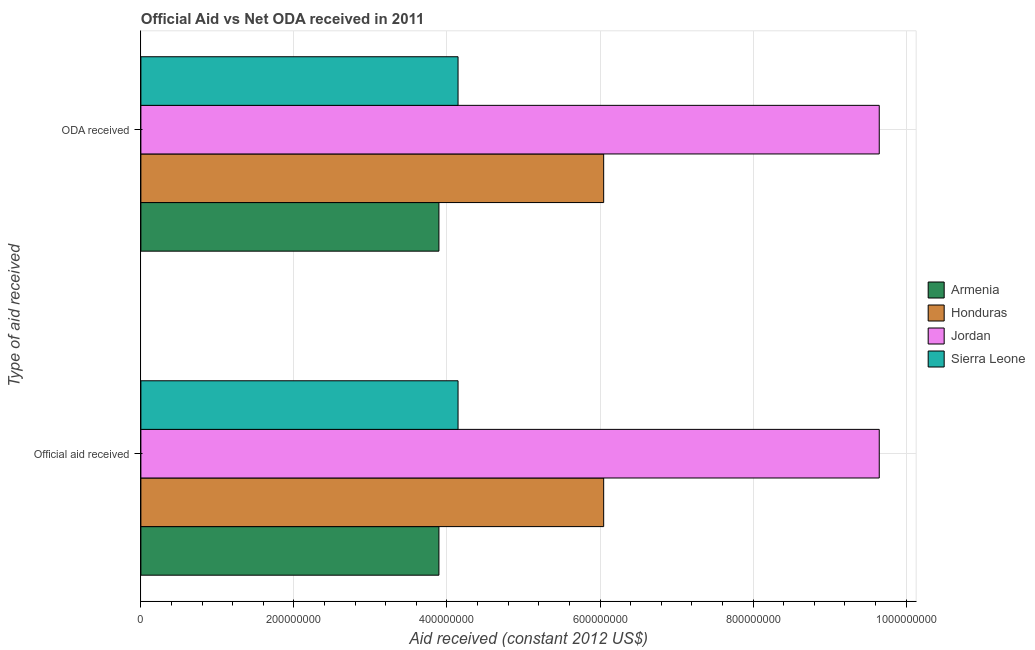How many groups of bars are there?
Ensure brevity in your answer.  2. How many bars are there on the 2nd tick from the top?
Offer a very short reply. 4. What is the label of the 1st group of bars from the top?
Provide a short and direct response. ODA received. What is the official aid received in Armenia?
Make the answer very short. 3.89e+08. Across all countries, what is the maximum official aid received?
Your response must be concise. 9.65e+08. Across all countries, what is the minimum oda received?
Give a very brief answer. 3.89e+08. In which country was the official aid received maximum?
Your answer should be compact. Jordan. In which country was the official aid received minimum?
Your answer should be very brief. Armenia. What is the total official aid received in the graph?
Provide a succinct answer. 2.37e+09. What is the difference between the official aid received in Armenia and that in Honduras?
Provide a succinct answer. -2.15e+08. What is the difference between the official aid received in Honduras and the oda received in Sierra Leone?
Ensure brevity in your answer.  1.90e+08. What is the average official aid received per country?
Provide a short and direct response. 5.93e+08. What is the ratio of the oda received in Armenia to that in Honduras?
Make the answer very short. 0.64. In how many countries, is the oda received greater than the average oda received taken over all countries?
Provide a succinct answer. 2. What does the 3rd bar from the top in ODA received represents?
Provide a succinct answer. Honduras. What does the 2nd bar from the bottom in Official aid received represents?
Provide a short and direct response. Honduras. How many bars are there?
Make the answer very short. 8. Are all the bars in the graph horizontal?
Keep it short and to the point. Yes. What is the difference between two consecutive major ticks on the X-axis?
Provide a succinct answer. 2.00e+08. Are the values on the major ticks of X-axis written in scientific E-notation?
Provide a succinct answer. No. Does the graph contain any zero values?
Keep it short and to the point. No. Does the graph contain grids?
Your answer should be compact. Yes. How many legend labels are there?
Make the answer very short. 4. How are the legend labels stacked?
Your answer should be compact. Vertical. What is the title of the graph?
Your answer should be compact. Official Aid vs Net ODA received in 2011 . What is the label or title of the X-axis?
Your answer should be compact. Aid received (constant 2012 US$). What is the label or title of the Y-axis?
Keep it short and to the point. Type of aid received. What is the Aid received (constant 2012 US$) in Armenia in Official aid received?
Give a very brief answer. 3.89e+08. What is the Aid received (constant 2012 US$) in Honduras in Official aid received?
Your response must be concise. 6.05e+08. What is the Aid received (constant 2012 US$) of Jordan in Official aid received?
Provide a short and direct response. 9.65e+08. What is the Aid received (constant 2012 US$) of Sierra Leone in Official aid received?
Offer a terse response. 4.14e+08. What is the Aid received (constant 2012 US$) of Armenia in ODA received?
Give a very brief answer. 3.89e+08. What is the Aid received (constant 2012 US$) in Honduras in ODA received?
Give a very brief answer. 6.05e+08. What is the Aid received (constant 2012 US$) of Jordan in ODA received?
Keep it short and to the point. 9.65e+08. What is the Aid received (constant 2012 US$) of Sierra Leone in ODA received?
Provide a succinct answer. 4.14e+08. Across all Type of aid received, what is the maximum Aid received (constant 2012 US$) of Armenia?
Offer a terse response. 3.89e+08. Across all Type of aid received, what is the maximum Aid received (constant 2012 US$) in Honduras?
Your answer should be very brief. 6.05e+08. Across all Type of aid received, what is the maximum Aid received (constant 2012 US$) in Jordan?
Your answer should be compact. 9.65e+08. Across all Type of aid received, what is the maximum Aid received (constant 2012 US$) in Sierra Leone?
Keep it short and to the point. 4.14e+08. Across all Type of aid received, what is the minimum Aid received (constant 2012 US$) in Armenia?
Ensure brevity in your answer.  3.89e+08. Across all Type of aid received, what is the minimum Aid received (constant 2012 US$) in Honduras?
Your answer should be compact. 6.05e+08. Across all Type of aid received, what is the minimum Aid received (constant 2012 US$) of Jordan?
Ensure brevity in your answer.  9.65e+08. Across all Type of aid received, what is the minimum Aid received (constant 2012 US$) in Sierra Leone?
Your answer should be compact. 4.14e+08. What is the total Aid received (constant 2012 US$) of Armenia in the graph?
Offer a terse response. 7.79e+08. What is the total Aid received (constant 2012 US$) of Honduras in the graph?
Your response must be concise. 1.21e+09. What is the total Aid received (constant 2012 US$) of Jordan in the graph?
Offer a very short reply. 1.93e+09. What is the total Aid received (constant 2012 US$) of Sierra Leone in the graph?
Provide a succinct answer. 8.29e+08. What is the difference between the Aid received (constant 2012 US$) of Jordan in Official aid received and that in ODA received?
Provide a short and direct response. 0. What is the difference between the Aid received (constant 2012 US$) in Sierra Leone in Official aid received and that in ODA received?
Ensure brevity in your answer.  0. What is the difference between the Aid received (constant 2012 US$) in Armenia in Official aid received and the Aid received (constant 2012 US$) in Honduras in ODA received?
Your response must be concise. -2.15e+08. What is the difference between the Aid received (constant 2012 US$) in Armenia in Official aid received and the Aid received (constant 2012 US$) in Jordan in ODA received?
Offer a terse response. -5.75e+08. What is the difference between the Aid received (constant 2012 US$) in Armenia in Official aid received and the Aid received (constant 2012 US$) in Sierra Leone in ODA received?
Provide a short and direct response. -2.50e+07. What is the difference between the Aid received (constant 2012 US$) in Honduras in Official aid received and the Aid received (constant 2012 US$) in Jordan in ODA received?
Your answer should be very brief. -3.60e+08. What is the difference between the Aid received (constant 2012 US$) in Honduras in Official aid received and the Aid received (constant 2012 US$) in Sierra Leone in ODA received?
Provide a short and direct response. 1.90e+08. What is the difference between the Aid received (constant 2012 US$) of Jordan in Official aid received and the Aid received (constant 2012 US$) of Sierra Leone in ODA received?
Give a very brief answer. 5.50e+08. What is the average Aid received (constant 2012 US$) in Armenia per Type of aid received?
Ensure brevity in your answer.  3.89e+08. What is the average Aid received (constant 2012 US$) of Honduras per Type of aid received?
Make the answer very short. 6.05e+08. What is the average Aid received (constant 2012 US$) of Jordan per Type of aid received?
Your response must be concise. 9.65e+08. What is the average Aid received (constant 2012 US$) in Sierra Leone per Type of aid received?
Make the answer very short. 4.14e+08. What is the difference between the Aid received (constant 2012 US$) of Armenia and Aid received (constant 2012 US$) of Honduras in Official aid received?
Offer a very short reply. -2.15e+08. What is the difference between the Aid received (constant 2012 US$) of Armenia and Aid received (constant 2012 US$) of Jordan in Official aid received?
Offer a terse response. -5.75e+08. What is the difference between the Aid received (constant 2012 US$) in Armenia and Aid received (constant 2012 US$) in Sierra Leone in Official aid received?
Your response must be concise. -2.50e+07. What is the difference between the Aid received (constant 2012 US$) of Honduras and Aid received (constant 2012 US$) of Jordan in Official aid received?
Offer a very short reply. -3.60e+08. What is the difference between the Aid received (constant 2012 US$) of Honduras and Aid received (constant 2012 US$) of Sierra Leone in Official aid received?
Give a very brief answer. 1.90e+08. What is the difference between the Aid received (constant 2012 US$) in Jordan and Aid received (constant 2012 US$) in Sierra Leone in Official aid received?
Your answer should be compact. 5.50e+08. What is the difference between the Aid received (constant 2012 US$) of Armenia and Aid received (constant 2012 US$) of Honduras in ODA received?
Offer a terse response. -2.15e+08. What is the difference between the Aid received (constant 2012 US$) in Armenia and Aid received (constant 2012 US$) in Jordan in ODA received?
Provide a succinct answer. -5.75e+08. What is the difference between the Aid received (constant 2012 US$) of Armenia and Aid received (constant 2012 US$) of Sierra Leone in ODA received?
Provide a short and direct response. -2.50e+07. What is the difference between the Aid received (constant 2012 US$) in Honduras and Aid received (constant 2012 US$) in Jordan in ODA received?
Offer a terse response. -3.60e+08. What is the difference between the Aid received (constant 2012 US$) of Honduras and Aid received (constant 2012 US$) of Sierra Leone in ODA received?
Make the answer very short. 1.90e+08. What is the difference between the Aid received (constant 2012 US$) in Jordan and Aid received (constant 2012 US$) in Sierra Leone in ODA received?
Offer a very short reply. 5.50e+08. What is the ratio of the Aid received (constant 2012 US$) in Honduras in Official aid received to that in ODA received?
Provide a succinct answer. 1. What is the difference between the highest and the second highest Aid received (constant 2012 US$) in Armenia?
Offer a very short reply. 0. What is the difference between the highest and the lowest Aid received (constant 2012 US$) in Honduras?
Offer a very short reply. 0. 